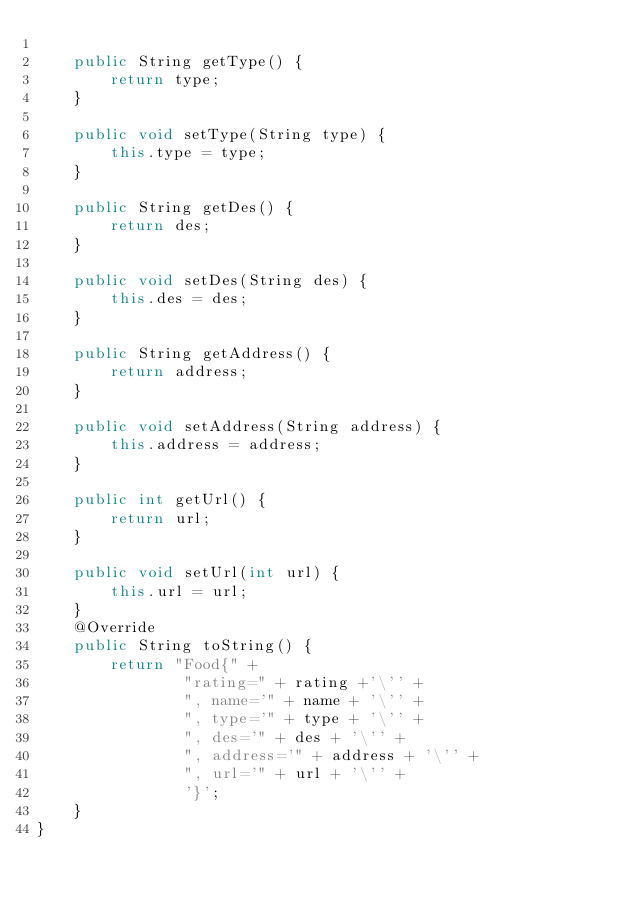Convert code to text. <code><loc_0><loc_0><loc_500><loc_500><_Java_>
    public String getType() {
        return type;
    }

    public void setType(String type) {
        this.type = type;
    }

    public String getDes() {
        return des;
    }

    public void setDes(String des) {
        this.des = des;
    }

    public String getAddress() {
        return address;
    }

    public void setAddress(String address) {
        this.address = address;
    }

    public int getUrl() {
        return url;
    }

    public void setUrl(int url) {
        this.url = url;
    }
    @Override
    public String toString() {
        return "Food{" +
                "rating=" + rating +'\'' +
                ", name='" + name + '\'' +
                ", type='" + type + '\'' +
                ", des='" + des + '\'' +
                ", address='" + address + '\'' +
                ", url='" + url + '\'' +
                '}';
    }
}
</code> 